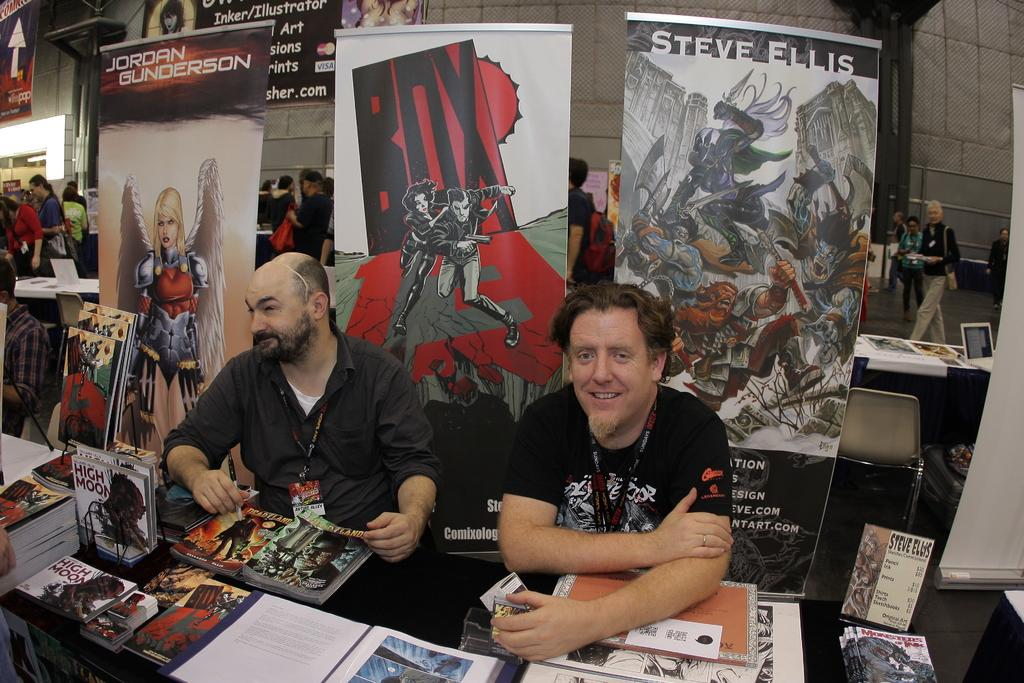<image>
Provide a brief description of the given image. Two men sit at a table on which is placed several copies of a High Moon graphic novel. 